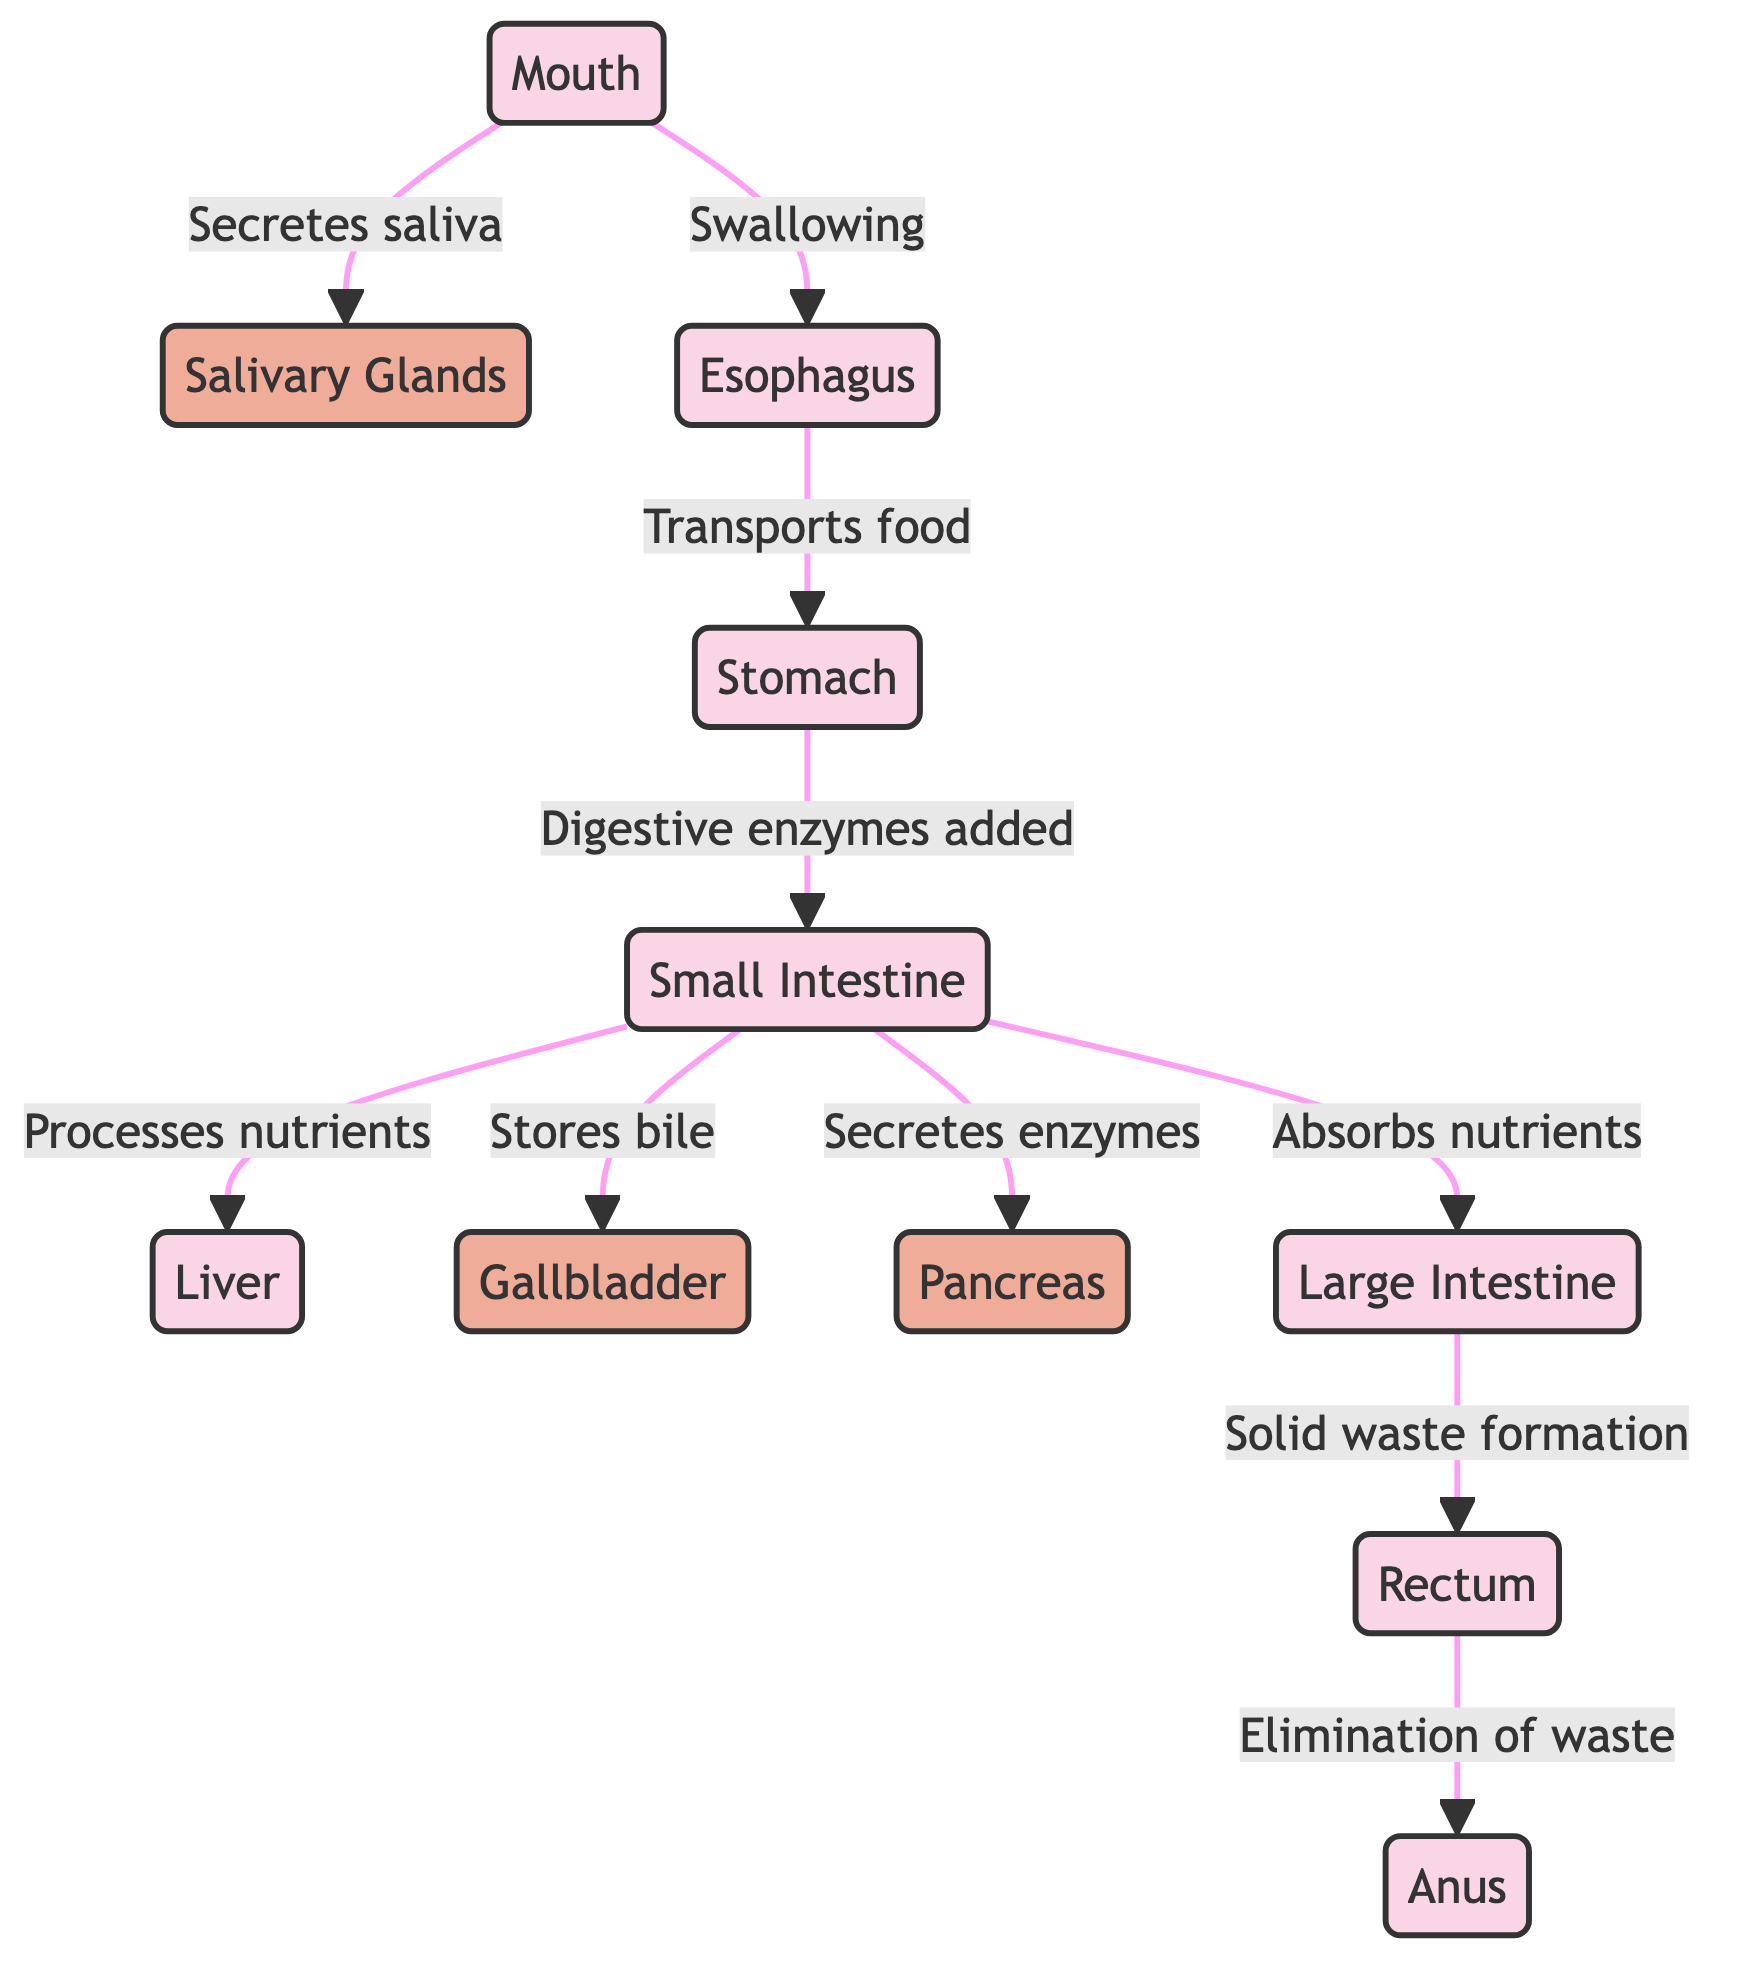What is the first organ involved in food breakdown? The diagram clearly indicates that the process of food breakdown begins in the Mouth, which is the first organ listed at the start of the flow.
Answer: Mouth How many glands are involved in the digestive process? The diagram identifies three glands: Salivary Glands, Gallbladder, and Pancreas. Therefore, there are a total of three glands involved.
Answer: 3 What is the function of the small intestine in the digestive system? According to the diagram, the small intestine has multiple functions, including processing nutrients, secreting enzymes from the pancreas, and absorbing nutrients, indicating its central role in digestion and absorption.
Answer: Processes nutrients Which organ comes after the stomach in the digestive pathway? The diagram shows that after food exits the stomach, it is directed towards the small intestine, which is the next organ in the sequence.
Answer: Small Intestine What role does the liver play in relation to the small intestine? The diagram indicates that the liver processes nutrients received from the small intestine, emphasizing the liver's role in nutrient metabolism and distribution.
Answer: Processes nutrients What is the last step of waste elimination in the digestive system? According to the diagram, the last step of waste elimination occurs at the anus, which is the endpoint in the digestive process for solid waste.
Answer: Anus Which organ stores bile, according to the diagram? The diagram specifies that the gallbladder stores bile, highlighting its function in the digestive system related to fat digestion.
Answer: Gallbladder How does food travel from the oral cavity to the stomach? The diagram shows that food travels from the oral cavity to the stomach via the esophagus, which serves as the transportation pathway connecting these two organs.
Answer: Esophagus What is the function of the rectum in the digestive system? The diagram states that the rectum is responsible for the elimination of waste, indicating its crucial role in the final stage of digestion.
Answer: Elimination of waste 